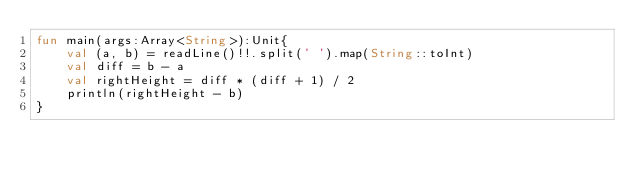Convert code to text. <code><loc_0><loc_0><loc_500><loc_500><_Kotlin_>fun main(args:Array<String>):Unit{
    val (a, b) = readLine()!!.split(' ').map(String::toInt)
    val diff = b - a
    val rightHeight = diff * (diff + 1) / 2
    println(rightHeight - b)
}</code> 